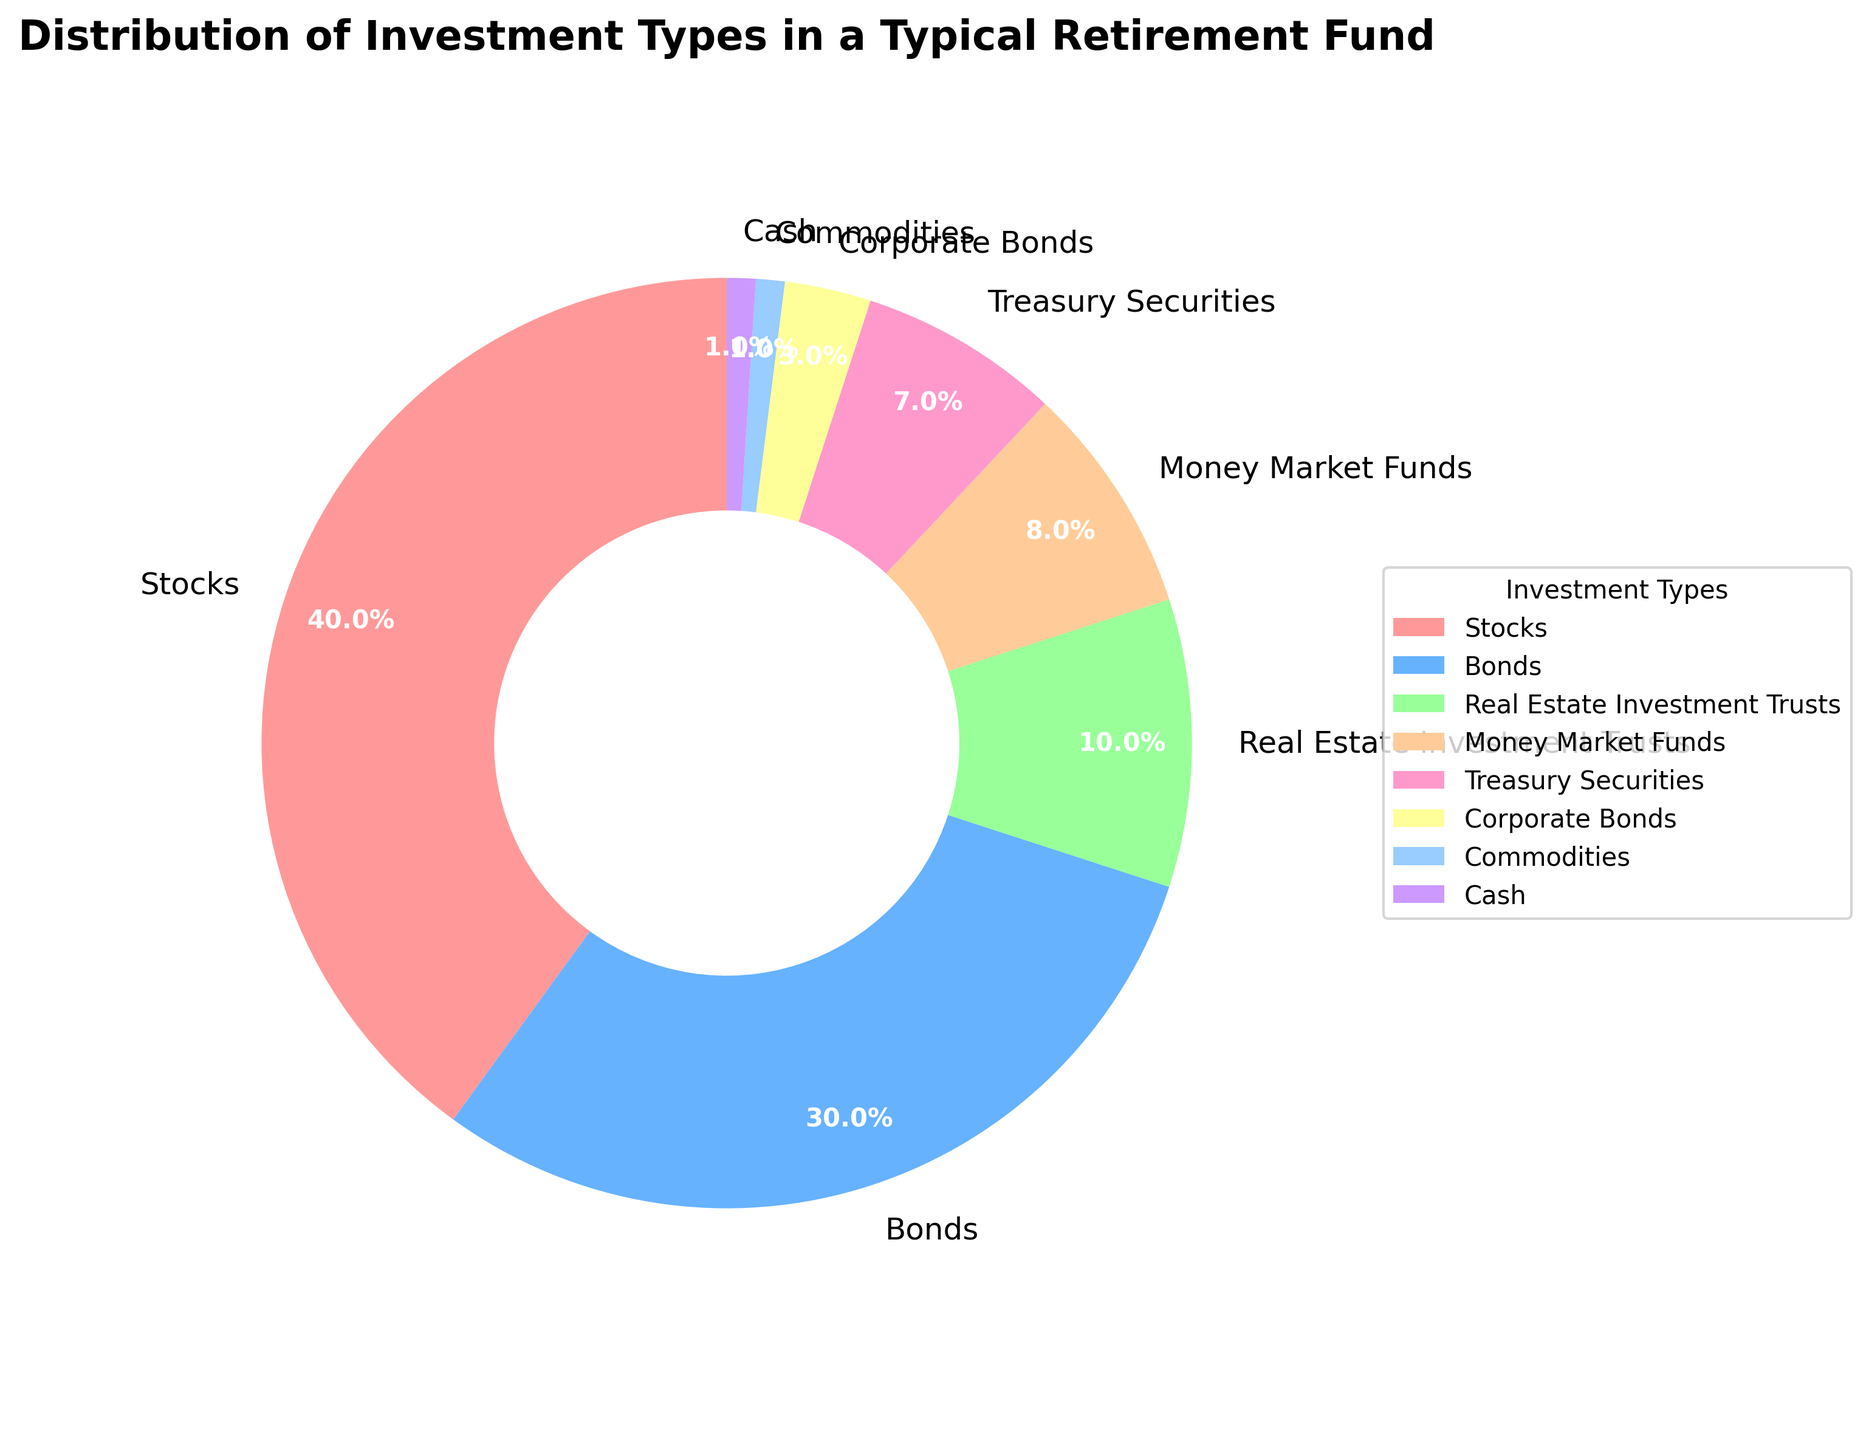What percentage of the retirement fund is comprised of Stocks and Bonds combined? The pie chart shows that Stocks make up 40% and Bonds comprise 30% of the retirement fund. By summing these percentages, you get 40 + 30 = 70%.
Answer: 70% Which investment type has the smallest percentage allocation? The pie chart indicates that two categories, Cash and Commodities, each have the smallest percentage allocation at 1%.
Answer: Cash, Commodities How many investment types collectively make up more than 75% of the retirement fund? From the pie chart, we sum the highest percentages until we exceed 75%: Stocks (40%) + Bonds (30%) = 70%; adding Real Estate Investment Trusts (10%) exceeds 75%, making a total of 3 investment types.
Answer: 3 Which investment types have a larger percentage allocation than Money Market Funds? By comparing the percentages shown in the pie chart: Stocks (40%), Bonds (30%), and Real Estate Investment Trusts (10%) all have larger allocations than Money Market Funds (8%).
Answer: Stocks, Bonds, Real Estate Investment Trusts Is the combined percentage of Treasury Securities and Corporate Bonds greater than the percentage of Real Estate Investment Trusts? Treasury Securities have a percentage of 7% and Corporate Bonds have 3%, adding up to 10%. Real Estate Investment Trusts also have 10%, so they are equal.
Answer: No What is the difference in percentage between Stocks and Treasury Securities? According to the pie chart, Stocks make up 40% and Treasury Securities make up 7%. The difference is 40 - 7 = 33%.
Answer: 33% If you combine the percentages of Money Market Funds and Real Estate Investment Trusts, does it exceed the percentage of Bonds? The pie chart shows Money Market Funds at 8% and Real Estate Investment Trusts at 10%. Summed together, they are 8 + 10 = 18%. Bonds are at 30%, so 18% does not exceed 30%.
Answer: No What is the total percentage of low-risk investment types (Treasury Securities, Corporate Bonds, Money Market Funds, Cash)? Adding up the percentages from the pie chart: Treasury Securities (7%), Corporate Bonds (3%), Money Market Funds (8%), Cash (1%) sum to 7 + 3 + 8 + 1 = 19%.
Answer: 19% Which investment type appears in the pie chart between Bonds and Real Estate Investment Trusts? The pie chart shows that Money Market Funds (8%) appears between Bonds (30%) and Real Estate Investment Trusts (10%) in the sequence around the circle.
Answer: Money Market Funds 